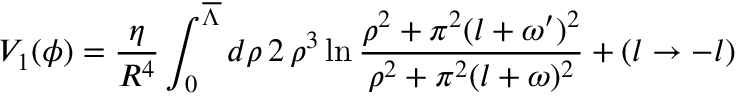<formula> <loc_0><loc_0><loc_500><loc_500>V _ { 1 } ( \phi ) = \frac { \eta } { R ^ { 4 } } \int _ { 0 } ^ { \overline { \Lambda } } { d \rho } \, 2 \, \rho ^ { 3 } \ln \frac { \rho ^ { 2 } + \pi ^ { 2 } ( l + \omega ^ { \prime } ) ^ { 2 } } { \rho ^ { 2 } + \pi ^ { 2 } ( l + \omega ) ^ { 2 } } + ( l \rightarrow - l )</formula> 